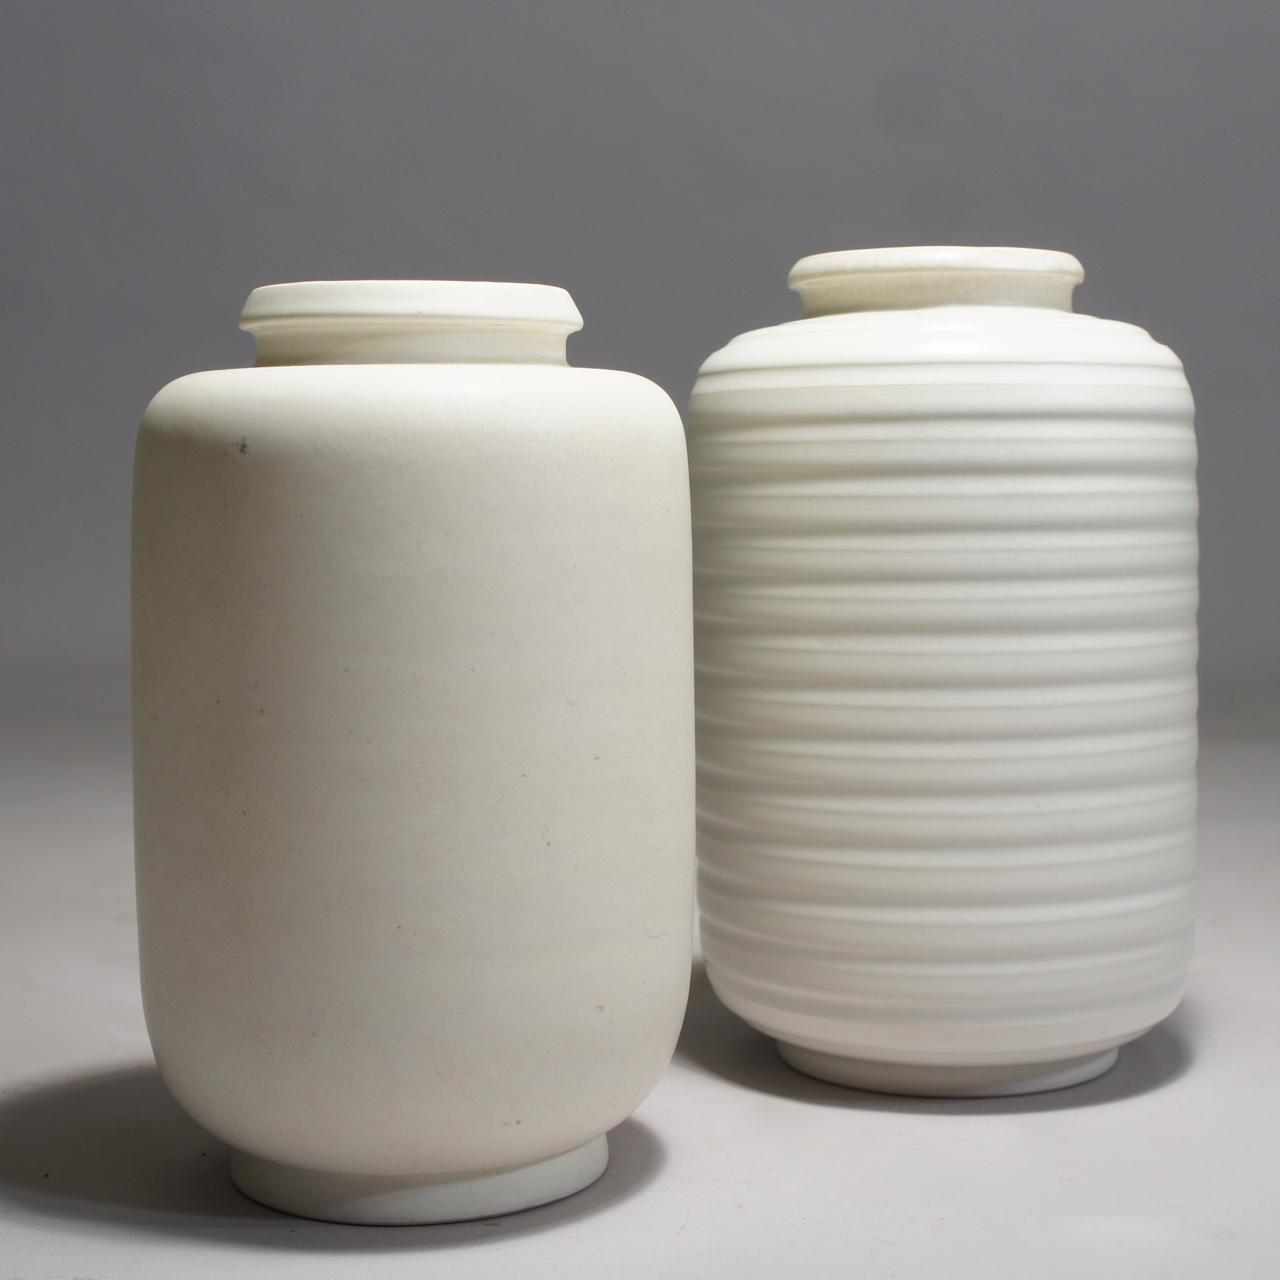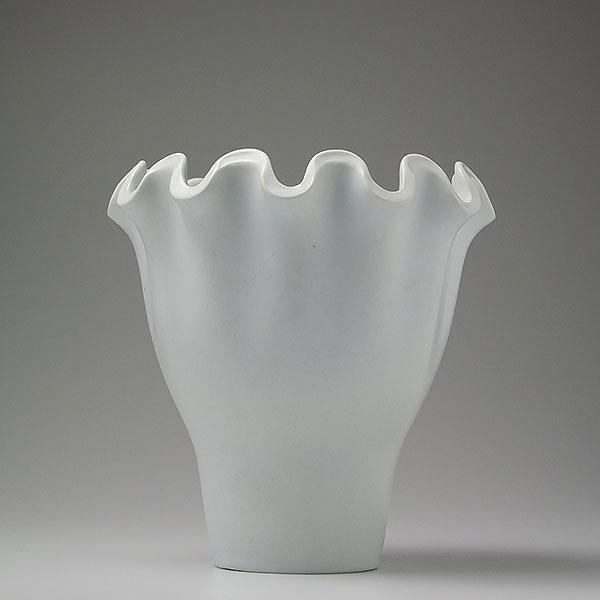The first image is the image on the left, the second image is the image on the right. Considering the images on both sides, is "One image shows two vases that are similar in size with top openings that are smaller than the body of the vase, but that are different designs." valid? Answer yes or no. Yes. The first image is the image on the left, the second image is the image on the right. For the images shown, is this caption "One image shows a neutral-colored vase with a base that is not round." true? Answer yes or no. No. 